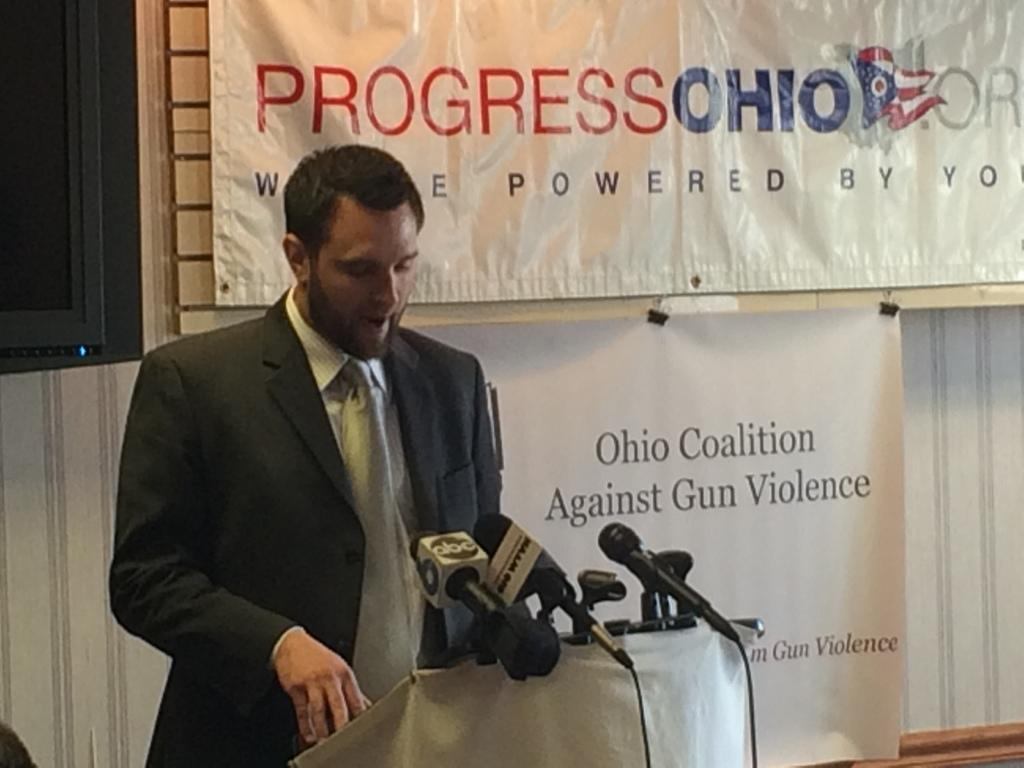What is the person in the image doing? The person is standing on the stage. What objects are present on the table in front of the person? There are microphones on a table in front of the person. What can be seen on the wall behind the person? There is a banner attached to the wall behind the person. How many bears are visible on the stage with the person? There are no bears present in the image; it only features a person standing on the stage. 